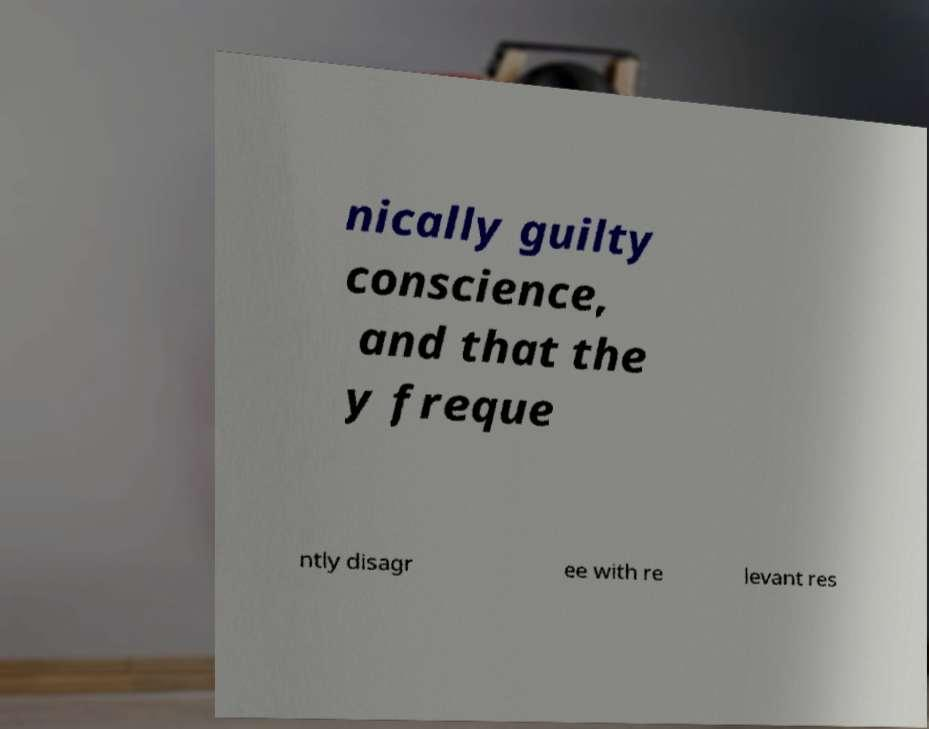Can you read and provide the text displayed in the image?This photo seems to have some interesting text. Can you extract and type it out for me? nically guilty conscience, and that the y freque ntly disagr ee with re levant res 